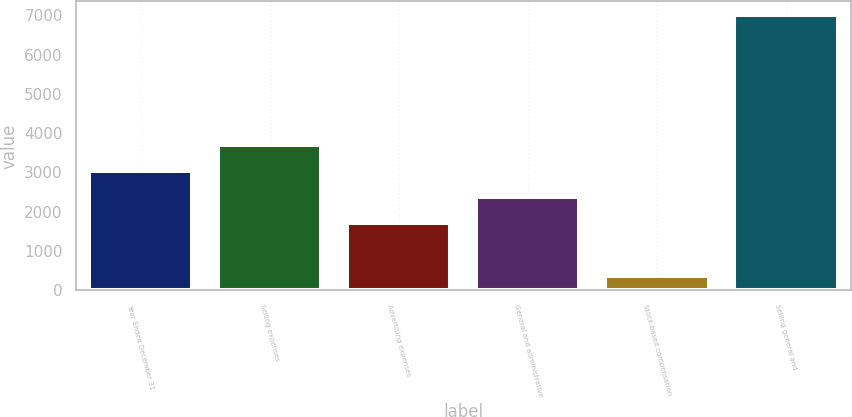Convert chart. <chart><loc_0><loc_0><loc_500><loc_500><bar_chart><fcel>Year Ended December 31<fcel>Selling expenses<fcel>Advertising expenses<fcel>General and administrative<fcel>Stock-based compensation<fcel>Selling general and<nl><fcel>3039.2<fcel>3702.8<fcel>1712<fcel>2375.6<fcel>365<fcel>7001<nl></chart> 